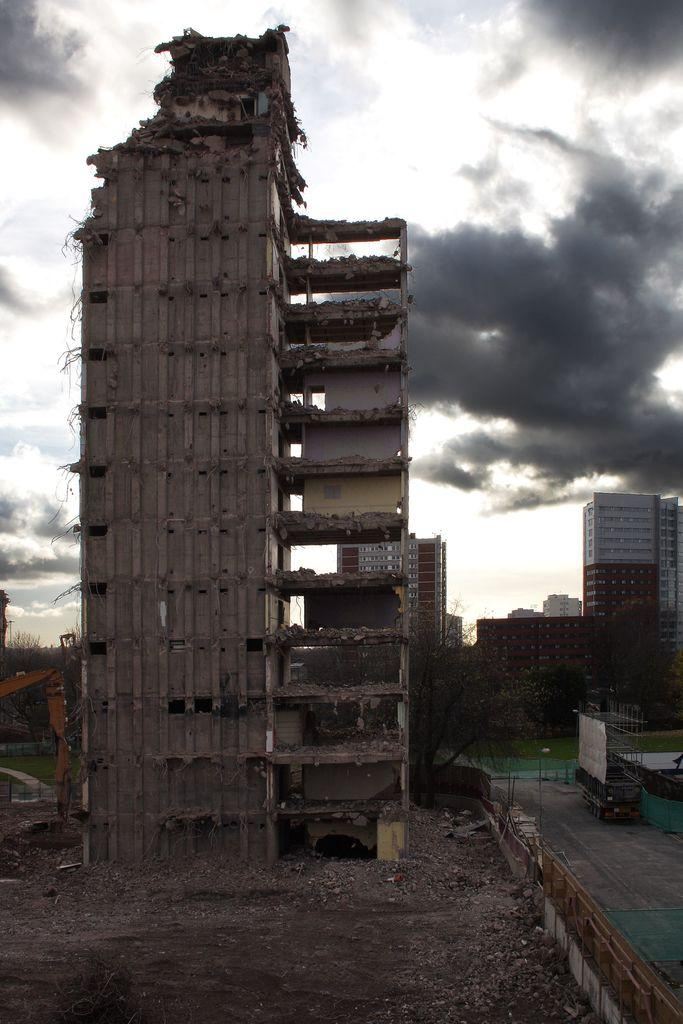What is the main subject of the image? The main subject of the image is a building. Can you describe the condition of the building? The building appears to be partially collapsed. What else can be seen in the image besides the building? There are other buildings visible in the background. What is visible at the top of the image? The sky is visible at the top of the image. How does the building help with the distribution of resources in the image? The image does not show any information about the distribution of resources, and the building's condition suggests it may not be functional. --- Facts: 1. There is a person sitting on a chair in the image. 2. The person is holding a book. 3. The book has a red cover. 4. There is a table next to the chair. 5. The table has a lamp on it. Absurd Topics: dance, ocean, parrot Conversation: What is the person in the image doing? The person in the image is sitting on a chair. What is the person holding in the image? The person is holding a book. Can you describe the book's appearance? The book has a red cover. What else can be seen in the image besides the person and the book? There is a table next to the chair, and a lamp is on the table. Reasoning: Let's think step by step in order to produce the conversation. We start by identifying the main subject of the image, which is the person sitting on a chair. Then, we describe what the person is holding, which is a book with a red cover. Next, we expand the conversation to include other objects visible in the image, such as the table and the lamp. Each question is designed to elicit a specific detail about the image that is known from the provided facts. Absurd Question/Answer: Can you see any parrots flying over the ocean in the image? There is no ocean or parrots present in the image; it features a person sitting on a chair holding a book. 